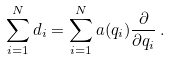<formula> <loc_0><loc_0><loc_500><loc_500>\sum _ { i = 1 } ^ { N } d _ { i } = \sum _ { i = 1 } ^ { N } a ( q _ { i } ) \frac { \partial } { \partial q _ { i } } \, .</formula> 